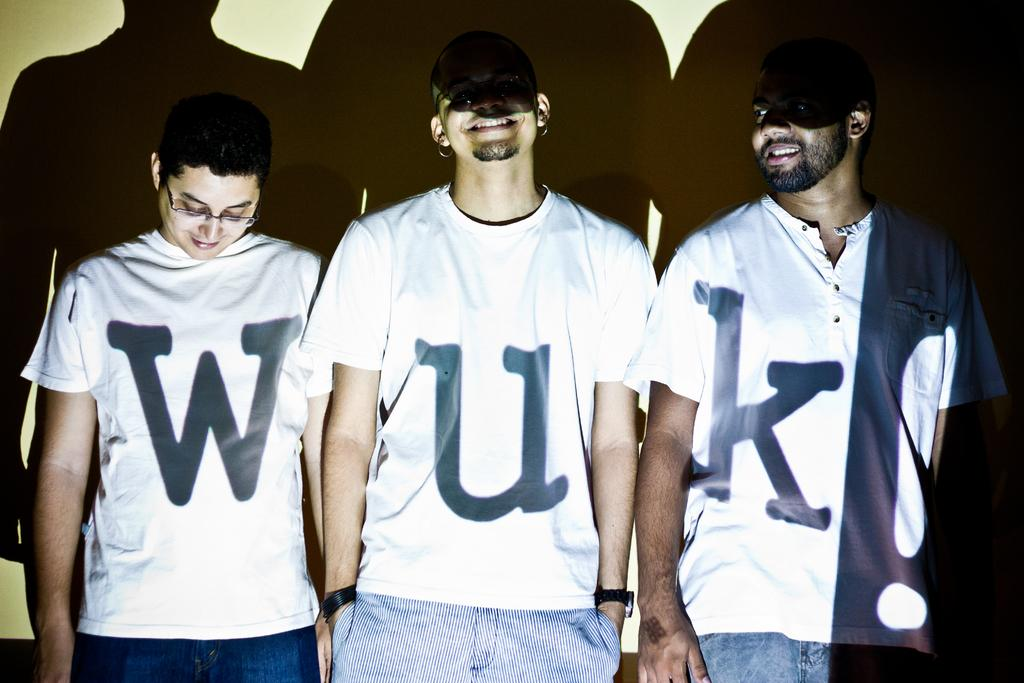<image>
Share a concise interpretation of the image provided. Three men are standing next to each other wearing shirts with the letters W U and K on them. 